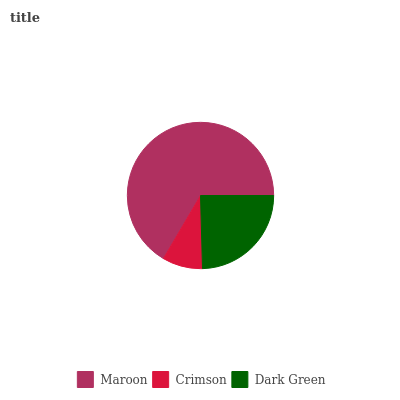Is Crimson the minimum?
Answer yes or no. Yes. Is Maroon the maximum?
Answer yes or no. Yes. Is Dark Green the minimum?
Answer yes or no. No. Is Dark Green the maximum?
Answer yes or no. No. Is Dark Green greater than Crimson?
Answer yes or no. Yes. Is Crimson less than Dark Green?
Answer yes or no. Yes. Is Crimson greater than Dark Green?
Answer yes or no. No. Is Dark Green less than Crimson?
Answer yes or no. No. Is Dark Green the high median?
Answer yes or no. Yes. Is Dark Green the low median?
Answer yes or no. Yes. Is Maroon the high median?
Answer yes or no. No. Is Maroon the low median?
Answer yes or no. No. 